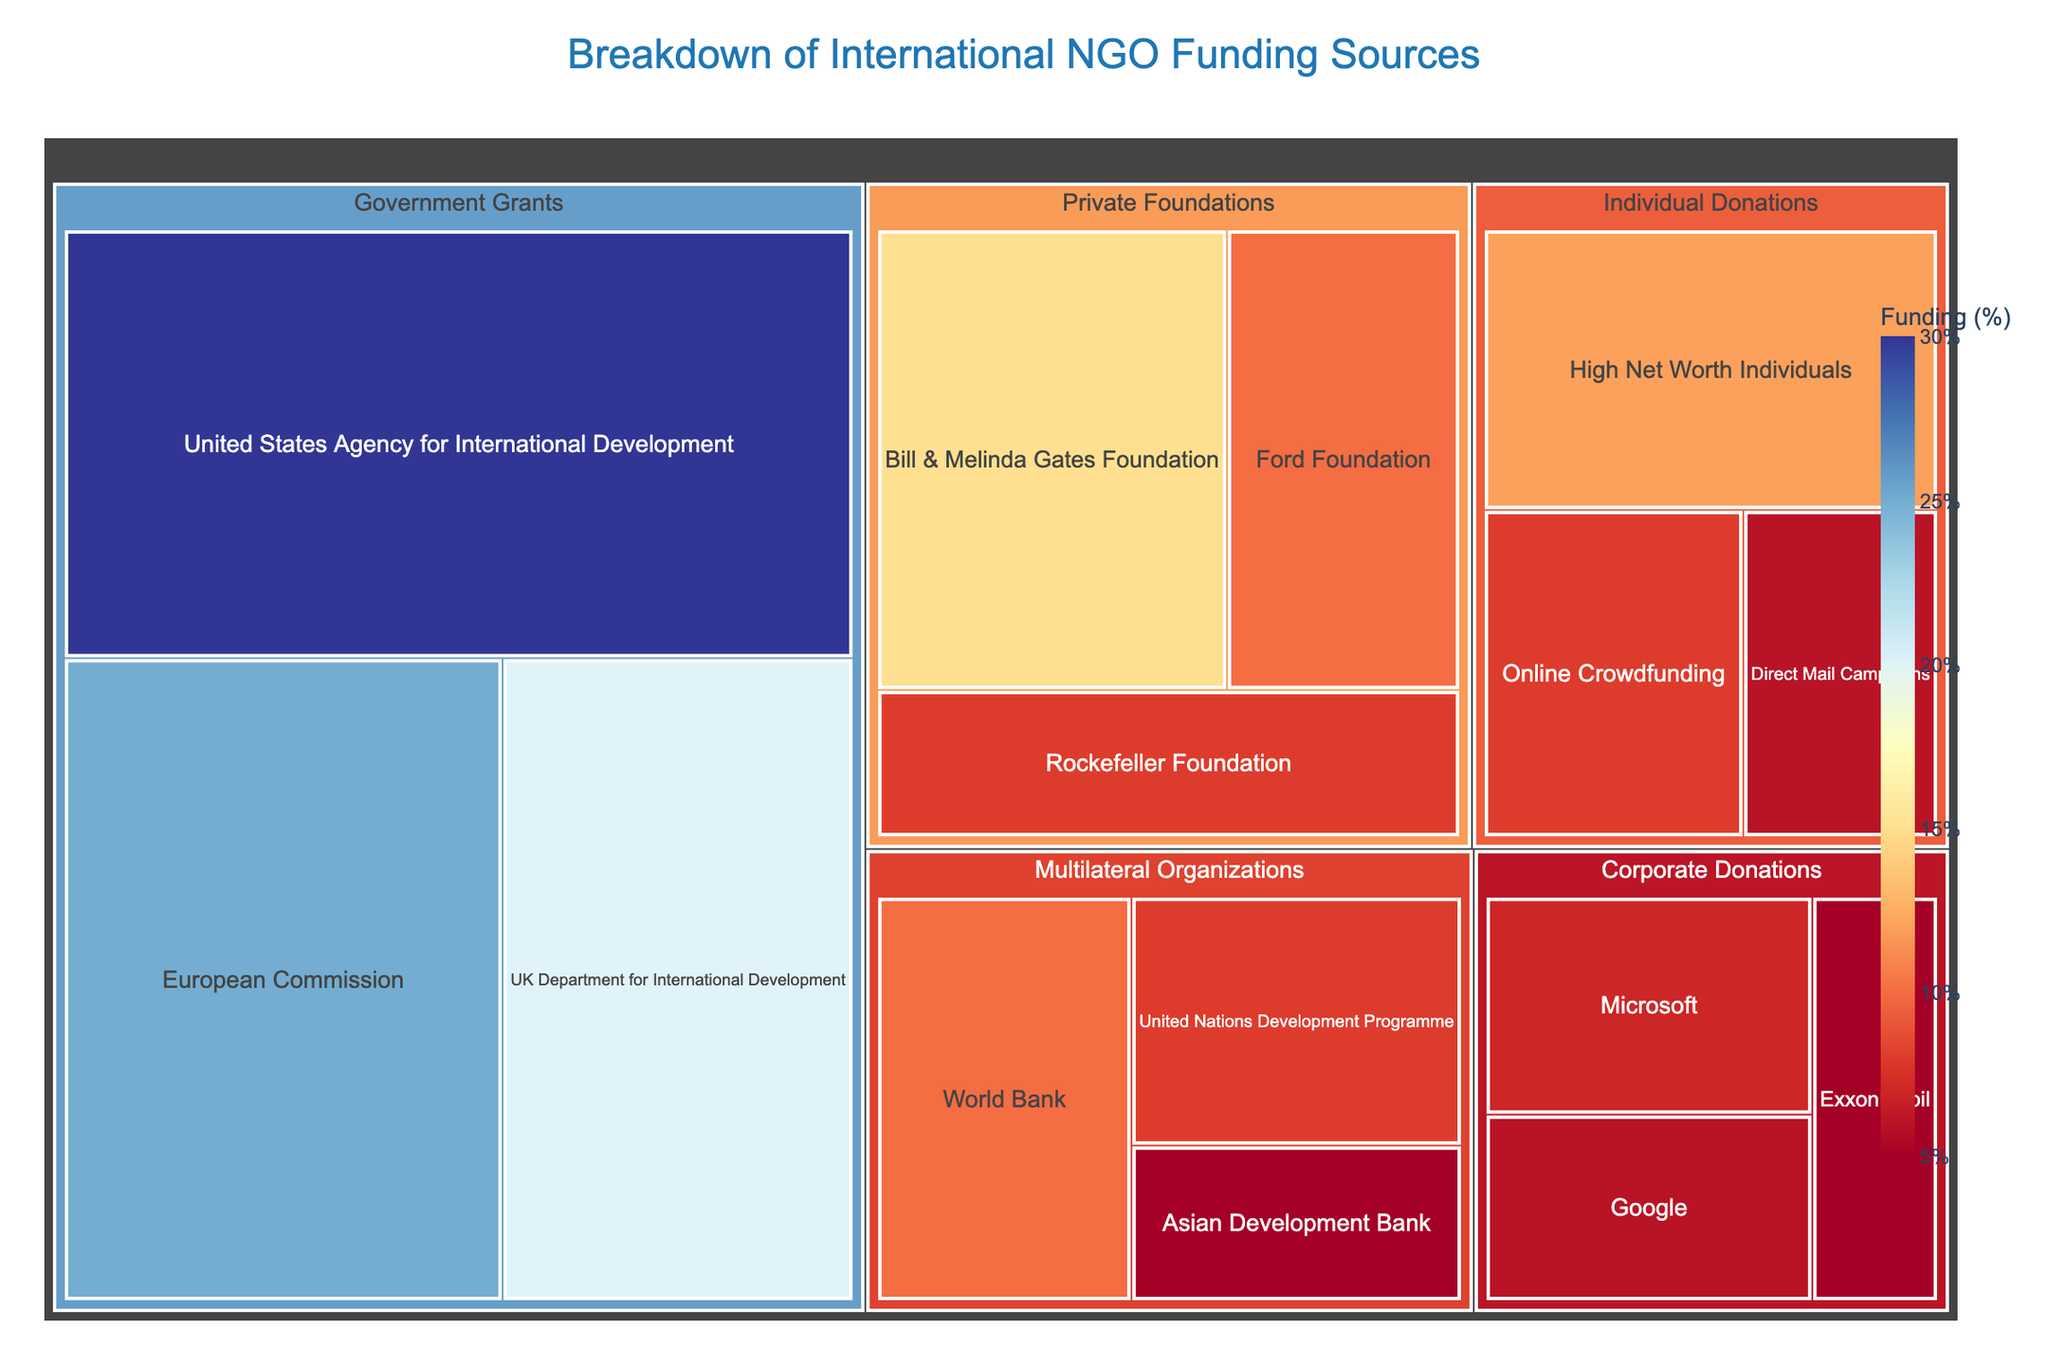What is the title of the figure? The title is usually located at the top of the figure. In this treemap, the title is "Breakdown of International NGO Funding Sources".
Answer: Breakdown of International NGO Funding Sources Which government grant source has the highest funding percentage? To determine the highest funding percentage among the government grant sources, look at the subcategories listed under "Government Grants". The United States Agency for International Development has the highest value of 30%.
Answer: United States Agency for International Development What is the total funding percentage from Government Grants? Sum the funding percentages of all subcategories under "Government Grants". These are: 30 + 25 + 20. Therefore, the total is 75%.
Answer: 75% Which category has the least total funding and what is its value? Compare the total funding values of each category by adding their subcategory values. The category with the least total funding will have the smallest sum. "Corporate Donations": 7 + 6 + 5 = 18, "Private Foundations": 15 + 10 + 8 = 33, "Government Grants": 30 + 25 + 20 = 75, "Individual Donations": 12 + 8 + 6 = 26, "Multilateral Organizations": 10 + 8 + 5 = 23. The category with the least total funding is "Corporate Donations" with a value of 18%.
Answer: Corporate Donations, 18% How does the funding from the Bill & Melinda Gates Foundation compare to that from the Ford Foundation? Compare the funding values of the two subcategories. The Bill & Melinda Gates Foundation has a value of 15%, while the Ford Foundation has a value of 10%. Therefore, Bill & Melinda Gates Foundation's funding is higher.
Answer: Bill & Melinda Gates Foundation has higher funding What is the average funding percentage of the Multilateral Organizations? To find the average, sum the funding percentages of the subcategories under "Multilateral Organizations" and divide by the number of subcategories: (10 + 8 + 5) / 3. Therefore, the average is 7.67%.
Answer: 7.67% What is the difference in funding percentages between the highest and lowest funded subcategories in Individual Donations? Identify the highest (High Net Worth Individuals, 12%) and the lowest (Direct Mail Campaigns, 6%) funded subcategories in "Individual Donations". Calculate the difference: 12 - 6 = 6%.
Answer: 6% Which subcategory in Individual Donations has the second highest funding percentage? List the subcategories under "Individual Donations": High Net Worth Individuals (12%), Online Crowdfunding (8%), Direct Mail Campaigns (6%). The second highest value is 8% for Online Crowdfunding.
Answer: Online Crowdfunding What is the total funding percentage from all Multilateral Organizations and Corporate Donations combined? Add up the total funding for "Multilateral Organizations" and "Corporate Donations": (10 + 8 + 5) + (7 + 6 + 5) = 23 + 18 = 41%.
Answer: 41% 